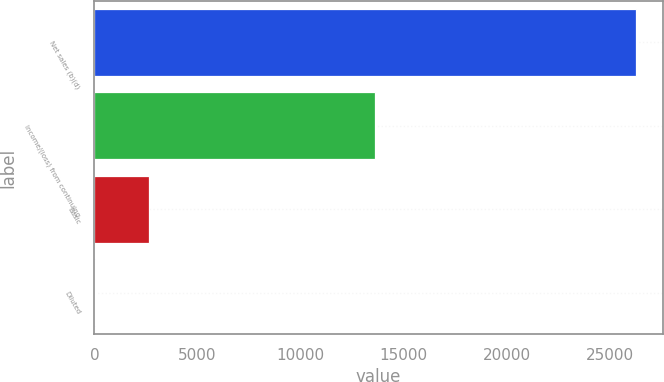Convert chart to OTSL. <chart><loc_0><loc_0><loc_500><loc_500><bar_chart><fcel>Net sales (b)(d)<fcel>Income/(loss) from continuing<fcel>Basic<fcel>Diluted<nl><fcel>26232<fcel>13612.3<fcel>2631.26<fcel>8.95<nl></chart> 